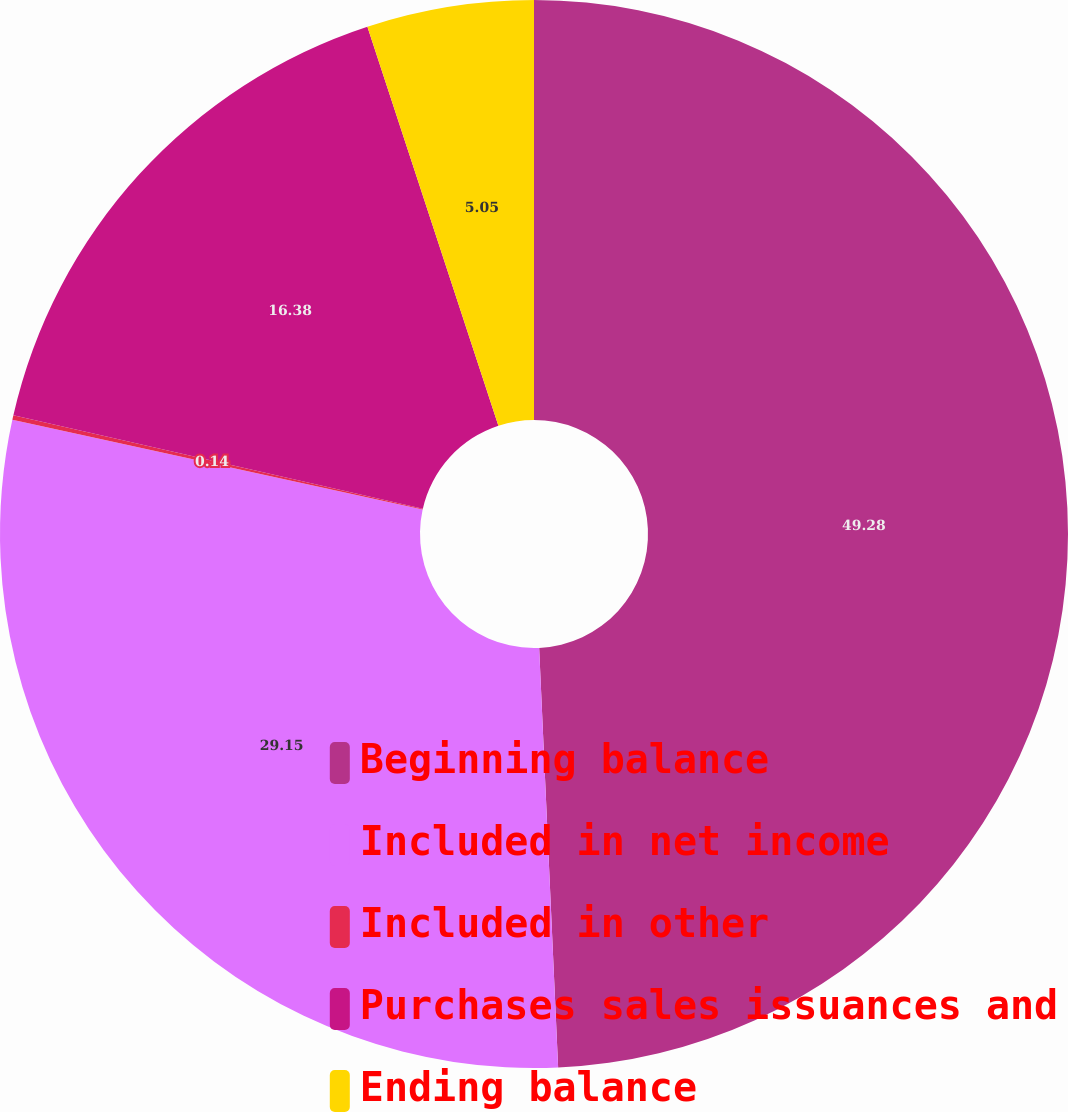Convert chart. <chart><loc_0><loc_0><loc_500><loc_500><pie_chart><fcel>Beginning balance<fcel>Included in net income<fcel>Included in other<fcel>Purchases sales issuances and<fcel>Ending balance<nl><fcel>49.28%<fcel>29.15%<fcel>0.14%<fcel>16.38%<fcel>5.05%<nl></chart> 